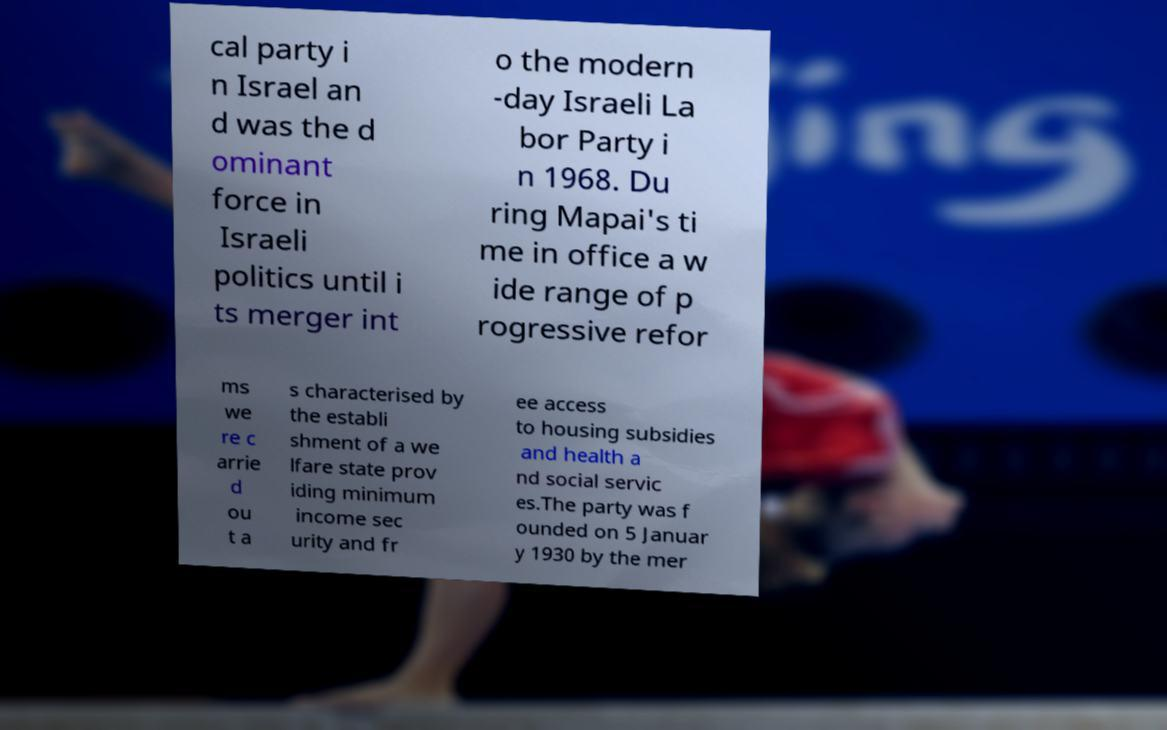For documentation purposes, I need the text within this image transcribed. Could you provide that? cal party i n Israel an d was the d ominant force in Israeli politics until i ts merger int o the modern -day Israeli La bor Party i n 1968. Du ring Mapai's ti me in office a w ide range of p rogressive refor ms we re c arrie d ou t a s characterised by the establi shment of a we lfare state prov iding minimum income sec urity and fr ee access to housing subsidies and health a nd social servic es.The party was f ounded on 5 Januar y 1930 by the mer 